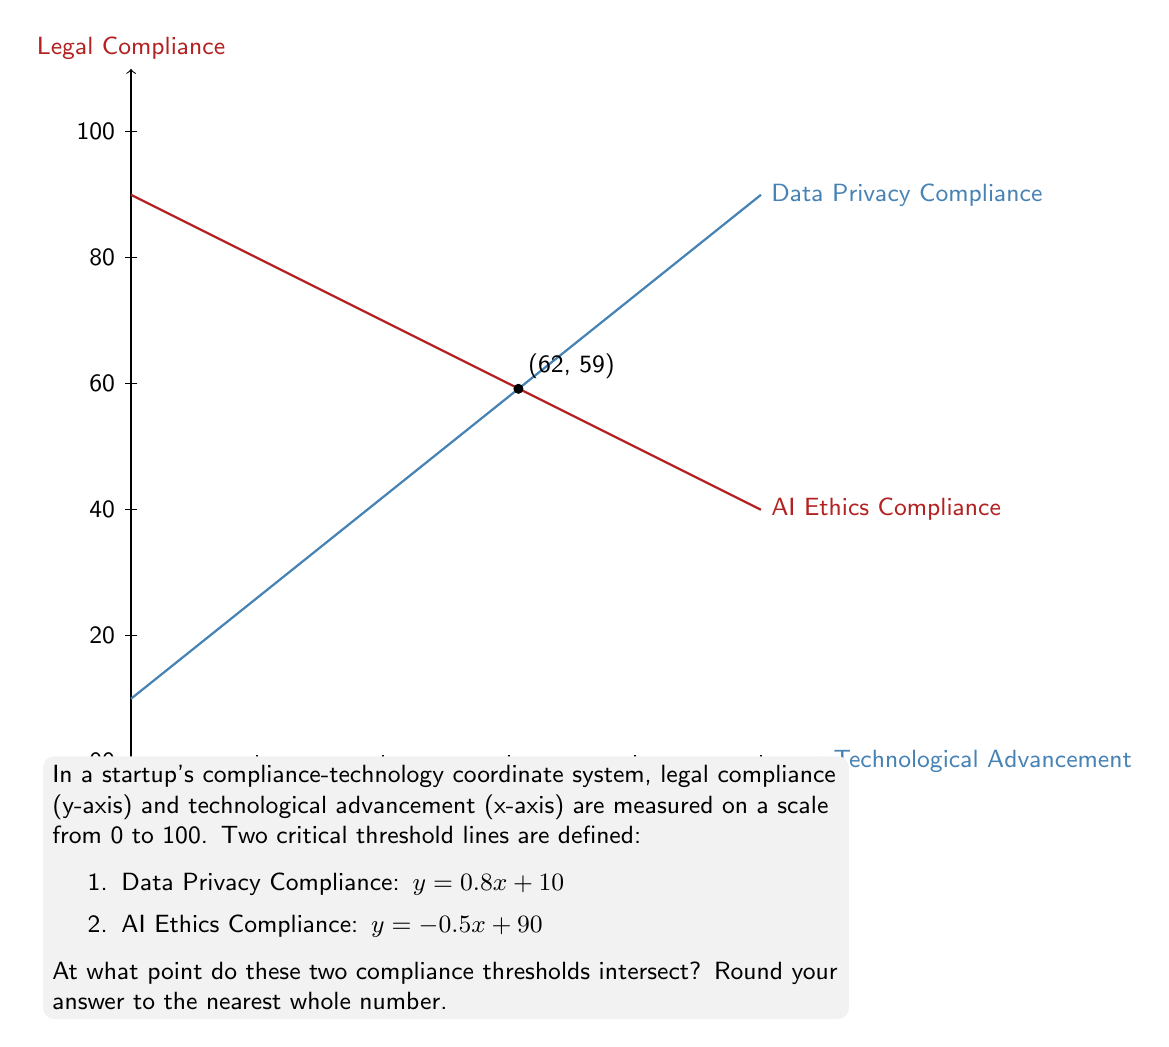Could you help me with this problem? To find the intersection point of the two lines, we need to solve the system of equations:

$$\begin{cases}
y = 0.8x + 10 \quad \text{(Data Privacy Compliance)}\\
y = -0.5x + 90 \quad \text{(AI Ethics Compliance)}
\end{cases}$$

Step 1: Set the equations equal to each other.
$0.8x + 10 = -0.5x + 90$

Step 2: Solve for x.
$0.8x + 0.5x = 90 - 10$
$1.3x = 80$
$x = \frac{80}{1.3} \approx 61.54$

Step 3: Substitute x back into either equation to find y.
Using the Data Privacy Compliance equation:
$y = 0.8(61.54) + 10 \approx 59.23$

Step 4: Round to the nearest whole number.
$x \approx 62$
$y \approx 59$

Therefore, the intersection point, rounded to the nearest whole number, is (62, 59).
Answer: (62, 59) 